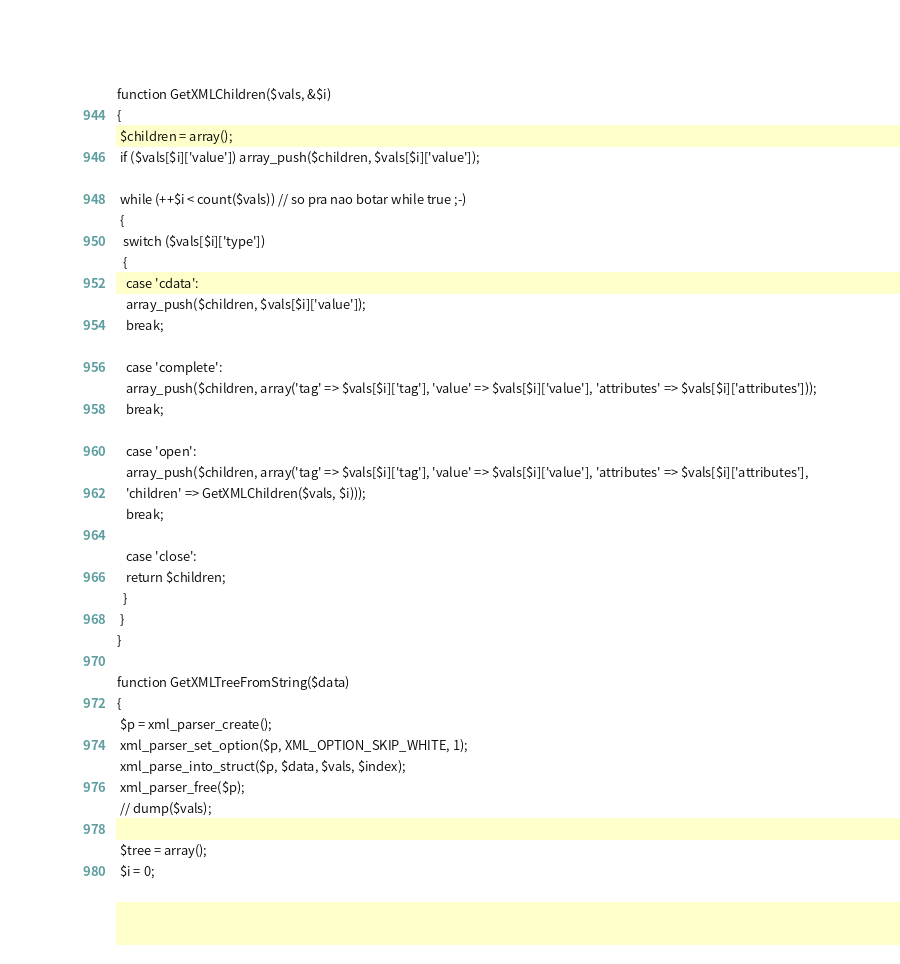<code> <loc_0><loc_0><loc_500><loc_500><_PHP_>function GetXMLChildren($vals, &$i)
{
 $children = array();
 if ($vals[$i]['value']) array_push($children, $vals[$i]['value']);

 while (++$i < count($vals)) // so pra nao botar while true ;-)
 {
  switch ($vals[$i]['type'])
  {
   case 'cdata':
   array_push($children, $vals[$i]['value']);
   break;

   case 'complete':
   array_push($children, array('tag' => $vals[$i]['tag'], 'value' => $vals[$i]['value'], 'attributes' => $vals[$i]['attributes']));
   break;

   case 'open':
   array_push($children, array('tag' => $vals[$i]['tag'], 'value' => $vals[$i]['value'], 'attributes' => $vals[$i]['attributes'],
   'children' => GetXMLChildren($vals, $i)));
   break;

   case 'close':
   return $children;
  }
 }
}

function GetXMLTreeFromString($data)
{
 $p = xml_parser_create();
 xml_parser_set_option($p, XML_OPTION_SKIP_WHITE, 1);
 xml_parse_into_struct($p, $data, $vals, $index);
 xml_parser_free($p);
 // dump($vals);

 $tree = array();
 $i = 0;</code> 